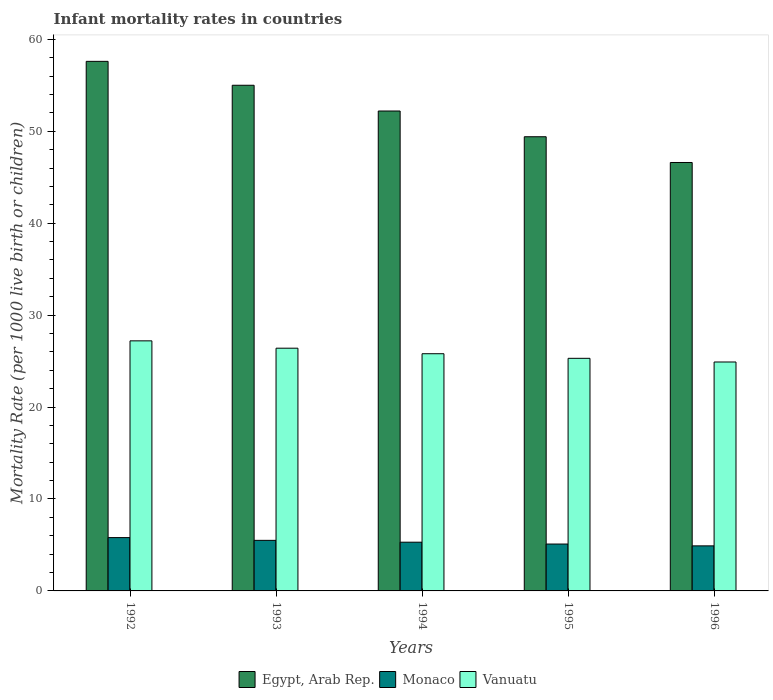How many bars are there on the 1st tick from the right?
Give a very brief answer. 3. What is the label of the 1st group of bars from the left?
Ensure brevity in your answer.  1992. In how many cases, is the number of bars for a given year not equal to the number of legend labels?
Ensure brevity in your answer.  0. What is the infant mortality rate in Vanuatu in 1992?
Ensure brevity in your answer.  27.2. Across all years, what is the maximum infant mortality rate in Monaco?
Give a very brief answer. 5.8. Across all years, what is the minimum infant mortality rate in Monaco?
Your response must be concise. 4.9. In which year was the infant mortality rate in Vanuatu maximum?
Make the answer very short. 1992. In which year was the infant mortality rate in Monaco minimum?
Give a very brief answer. 1996. What is the total infant mortality rate in Monaco in the graph?
Your answer should be compact. 26.6. What is the difference between the infant mortality rate in Egypt, Arab Rep. in 1993 and that in 1995?
Ensure brevity in your answer.  5.6. What is the difference between the infant mortality rate in Egypt, Arab Rep. in 1994 and the infant mortality rate in Monaco in 1995?
Your answer should be compact. 47.1. What is the average infant mortality rate in Vanuatu per year?
Offer a very short reply. 25.92. In the year 1996, what is the difference between the infant mortality rate in Egypt, Arab Rep. and infant mortality rate in Vanuatu?
Provide a succinct answer. 21.7. In how many years, is the infant mortality rate in Monaco greater than 14?
Make the answer very short. 0. What is the ratio of the infant mortality rate in Monaco in 1995 to that in 1996?
Make the answer very short. 1.04. Is the infant mortality rate in Monaco in 1992 less than that in 1995?
Offer a terse response. No. What is the difference between the highest and the second highest infant mortality rate in Vanuatu?
Provide a succinct answer. 0.8. What is the difference between the highest and the lowest infant mortality rate in Vanuatu?
Your answer should be compact. 2.3. Is the sum of the infant mortality rate in Vanuatu in 1993 and 1994 greater than the maximum infant mortality rate in Monaco across all years?
Provide a succinct answer. Yes. What does the 2nd bar from the left in 1993 represents?
Keep it short and to the point. Monaco. What does the 2nd bar from the right in 1993 represents?
Keep it short and to the point. Monaco. Are all the bars in the graph horizontal?
Offer a very short reply. No. How many years are there in the graph?
Offer a very short reply. 5. What is the difference between two consecutive major ticks on the Y-axis?
Provide a succinct answer. 10. Are the values on the major ticks of Y-axis written in scientific E-notation?
Your answer should be compact. No. Does the graph contain any zero values?
Offer a very short reply. No. Does the graph contain grids?
Your response must be concise. No. How are the legend labels stacked?
Provide a succinct answer. Horizontal. What is the title of the graph?
Offer a terse response. Infant mortality rates in countries. Does "Malaysia" appear as one of the legend labels in the graph?
Your response must be concise. No. What is the label or title of the Y-axis?
Keep it short and to the point. Mortality Rate (per 1000 live birth or children). What is the Mortality Rate (per 1000 live birth or children) of Egypt, Arab Rep. in 1992?
Give a very brief answer. 57.6. What is the Mortality Rate (per 1000 live birth or children) in Monaco in 1992?
Your response must be concise. 5.8. What is the Mortality Rate (per 1000 live birth or children) in Vanuatu in 1992?
Give a very brief answer. 27.2. What is the Mortality Rate (per 1000 live birth or children) of Vanuatu in 1993?
Offer a terse response. 26.4. What is the Mortality Rate (per 1000 live birth or children) in Egypt, Arab Rep. in 1994?
Your response must be concise. 52.2. What is the Mortality Rate (per 1000 live birth or children) of Vanuatu in 1994?
Your answer should be compact. 25.8. What is the Mortality Rate (per 1000 live birth or children) of Egypt, Arab Rep. in 1995?
Give a very brief answer. 49.4. What is the Mortality Rate (per 1000 live birth or children) in Monaco in 1995?
Keep it short and to the point. 5.1. What is the Mortality Rate (per 1000 live birth or children) in Vanuatu in 1995?
Make the answer very short. 25.3. What is the Mortality Rate (per 1000 live birth or children) in Egypt, Arab Rep. in 1996?
Your answer should be very brief. 46.6. What is the Mortality Rate (per 1000 live birth or children) of Monaco in 1996?
Provide a short and direct response. 4.9. What is the Mortality Rate (per 1000 live birth or children) in Vanuatu in 1996?
Offer a very short reply. 24.9. Across all years, what is the maximum Mortality Rate (per 1000 live birth or children) in Egypt, Arab Rep.?
Your answer should be very brief. 57.6. Across all years, what is the maximum Mortality Rate (per 1000 live birth or children) of Monaco?
Provide a short and direct response. 5.8. Across all years, what is the maximum Mortality Rate (per 1000 live birth or children) in Vanuatu?
Offer a very short reply. 27.2. Across all years, what is the minimum Mortality Rate (per 1000 live birth or children) of Egypt, Arab Rep.?
Your response must be concise. 46.6. Across all years, what is the minimum Mortality Rate (per 1000 live birth or children) in Vanuatu?
Offer a very short reply. 24.9. What is the total Mortality Rate (per 1000 live birth or children) in Egypt, Arab Rep. in the graph?
Make the answer very short. 260.8. What is the total Mortality Rate (per 1000 live birth or children) of Monaco in the graph?
Offer a very short reply. 26.6. What is the total Mortality Rate (per 1000 live birth or children) in Vanuatu in the graph?
Give a very brief answer. 129.6. What is the difference between the Mortality Rate (per 1000 live birth or children) of Egypt, Arab Rep. in 1992 and that in 1993?
Make the answer very short. 2.6. What is the difference between the Mortality Rate (per 1000 live birth or children) of Vanuatu in 1992 and that in 1993?
Provide a short and direct response. 0.8. What is the difference between the Mortality Rate (per 1000 live birth or children) in Monaco in 1992 and that in 1994?
Your answer should be very brief. 0.5. What is the difference between the Mortality Rate (per 1000 live birth or children) of Vanuatu in 1992 and that in 1995?
Provide a short and direct response. 1.9. What is the difference between the Mortality Rate (per 1000 live birth or children) of Egypt, Arab Rep. in 1992 and that in 1996?
Your answer should be compact. 11. What is the difference between the Mortality Rate (per 1000 live birth or children) of Vanuatu in 1992 and that in 1996?
Give a very brief answer. 2.3. What is the difference between the Mortality Rate (per 1000 live birth or children) of Egypt, Arab Rep. in 1993 and that in 1994?
Keep it short and to the point. 2.8. What is the difference between the Mortality Rate (per 1000 live birth or children) in Egypt, Arab Rep. in 1993 and that in 1995?
Keep it short and to the point. 5.6. What is the difference between the Mortality Rate (per 1000 live birth or children) in Monaco in 1993 and that in 1995?
Give a very brief answer. 0.4. What is the difference between the Mortality Rate (per 1000 live birth or children) in Vanuatu in 1993 and that in 1995?
Provide a short and direct response. 1.1. What is the difference between the Mortality Rate (per 1000 live birth or children) in Egypt, Arab Rep. in 1993 and that in 1996?
Ensure brevity in your answer.  8.4. What is the difference between the Mortality Rate (per 1000 live birth or children) of Vanuatu in 1994 and that in 1995?
Your response must be concise. 0.5. What is the difference between the Mortality Rate (per 1000 live birth or children) of Vanuatu in 1994 and that in 1996?
Provide a short and direct response. 0.9. What is the difference between the Mortality Rate (per 1000 live birth or children) of Egypt, Arab Rep. in 1995 and that in 1996?
Your answer should be compact. 2.8. What is the difference between the Mortality Rate (per 1000 live birth or children) in Vanuatu in 1995 and that in 1996?
Ensure brevity in your answer.  0.4. What is the difference between the Mortality Rate (per 1000 live birth or children) of Egypt, Arab Rep. in 1992 and the Mortality Rate (per 1000 live birth or children) of Monaco in 1993?
Your response must be concise. 52.1. What is the difference between the Mortality Rate (per 1000 live birth or children) of Egypt, Arab Rep. in 1992 and the Mortality Rate (per 1000 live birth or children) of Vanuatu in 1993?
Give a very brief answer. 31.2. What is the difference between the Mortality Rate (per 1000 live birth or children) in Monaco in 1992 and the Mortality Rate (per 1000 live birth or children) in Vanuatu in 1993?
Your answer should be very brief. -20.6. What is the difference between the Mortality Rate (per 1000 live birth or children) in Egypt, Arab Rep. in 1992 and the Mortality Rate (per 1000 live birth or children) in Monaco in 1994?
Your response must be concise. 52.3. What is the difference between the Mortality Rate (per 1000 live birth or children) of Egypt, Arab Rep. in 1992 and the Mortality Rate (per 1000 live birth or children) of Vanuatu in 1994?
Provide a short and direct response. 31.8. What is the difference between the Mortality Rate (per 1000 live birth or children) of Egypt, Arab Rep. in 1992 and the Mortality Rate (per 1000 live birth or children) of Monaco in 1995?
Your response must be concise. 52.5. What is the difference between the Mortality Rate (per 1000 live birth or children) of Egypt, Arab Rep. in 1992 and the Mortality Rate (per 1000 live birth or children) of Vanuatu in 1995?
Offer a terse response. 32.3. What is the difference between the Mortality Rate (per 1000 live birth or children) of Monaco in 1992 and the Mortality Rate (per 1000 live birth or children) of Vanuatu in 1995?
Your response must be concise. -19.5. What is the difference between the Mortality Rate (per 1000 live birth or children) of Egypt, Arab Rep. in 1992 and the Mortality Rate (per 1000 live birth or children) of Monaco in 1996?
Your response must be concise. 52.7. What is the difference between the Mortality Rate (per 1000 live birth or children) of Egypt, Arab Rep. in 1992 and the Mortality Rate (per 1000 live birth or children) of Vanuatu in 1996?
Offer a very short reply. 32.7. What is the difference between the Mortality Rate (per 1000 live birth or children) in Monaco in 1992 and the Mortality Rate (per 1000 live birth or children) in Vanuatu in 1996?
Your answer should be compact. -19.1. What is the difference between the Mortality Rate (per 1000 live birth or children) in Egypt, Arab Rep. in 1993 and the Mortality Rate (per 1000 live birth or children) in Monaco in 1994?
Offer a terse response. 49.7. What is the difference between the Mortality Rate (per 1000 live birth or children) in Egypt, Arab Rep. in 1993 and the Mortality Rate (per 1000 live birth or children) in Vanuatu in 1994?
Your answer should be very brief. 29.2. What is the difference between the Mortality Rate (per 1000 live birth or children) of Monaco in 1993 and the Mortality Rate (per 1000 live birth or children) of Vanuatu in 1994?
Make the answer very short. -20.3. What is the difference between the Mortality Rate (per 1000 live birth or children) in Egypt, Arab Rep. in 1993 and the Mortality Rate (per 1000 live birth or children) in Monaco in 1995?
Your answer should be compact. 49.9. What is the difference between the Mortality Rate (per 1000 live birth or children) of Egypt, Arab Rep. in 1993 and the Mortality Rate (per 1000 live birth or children) of Vanuatu in 1995?
Offer a terse response. 29.7. What is the difference between the Mortality Rate (per 1000 live birth or children) in Monaco in 1993 and the Mortality Rate (per 1000 live birth or children) in Vanuatu in 1995?
Ensure brevity in your answer.  -19.8. What is the difference between the Mortality Rate (per 1000 live birth or children) in Egypt, Arab Rep. in 1993 and the Mortality Rate (per 1000 live birth or children) in Monaco in 1996?
Provide a short and direct response. 50.1. What is the difference between the Mortality Rate (per 1000 live birth or children) in Egypt, Arab Rep. in 1993 and the Mortality Rate (per 1000 live birth or children) in Vanuatu in 1996?
Your answer should be compact. 30.1. What is the difference between the Mortality Rate (per 1000 live birth or children) of Monaco in 1993 and the Mortality Rate (per 1000 live birth or children) of Vanuatu in 1996?
Provide a succinct answer. -19.4. What is the difference between the Mortality Rate (per 1000 live birth or children) of Egypt, Arab Rep. in 1994 and the Mortality Rate (per 1000 live birth or children) of Monaco in 1995?
Give a very brief answer. 47.1. What is the difference between the Mortality Rate (per 1000 live birth or children) of Egypt, Arab Rep. in 1994 and the Mortality Rate (per 1000 live birth or children) of Vanuatu in 1995?
Your answer should be compact. 26.9. What is the difference between the Mortality Rate (per 1000 live birth or children) of Monaco in 1994 and the Mortality Rate (per 1000 live birth or children) of Vanuatu in 1995?
Provide a succinct answer. -20. What is the difference between the Mortality Rate (per 1000 live birth or children) of Egypt, Arab Rep. in 1994 and the Mortality Rate (per 1000 live birth or children) of Monaco in 1996?
Ensure brevity in your answer.  47.3. What is the difference between the Mortality Rate (per 1000 live birth or children) in Egypt, Arab Rep. in 1994 and the Mortality Rate (per 1000 live birth or children) in Vanuatu in 1996?
Your response must be concise. 27.3. What is the difference between the Mortality Rate (per 1000 live birth or children) in Monaco in 1994 and the Mortality Rate (per 1000 live birth or children) in Vanuatu in 1996?
Offer a terse response. -19.6. What is the difference between the Mortality Rate (per 1000 live birth or children) in Egypt, Arab Rep. in 1995 and the Mortality Rate (per 1000 live birth or children) in Monaco in 1996?
Keep it short and to the point. 44.5. What is the difference between the Mortality Rate (per 1000 live birth or children) of Egypt, Arab Rep. in 1995 and the Mortality Rate (per 1000 live birth or children) of Vanuatu in 1996?
Ensure brevity in your answer.  24.5. What is the difference between the Mortality Rate (per 1000 live birth or children) in Monaco in 1995 and the Mortality Rate (per 1000 live birth or children) in Vanuatu in 1996?
Your response must be concise. -19.8. What is the average Mortality Rate (per 1000 live birth or children) of Egypt, Arab Rep. per year?
Make the answer very short. 52.16. What is the average Mortality Rate (per 1000 live birth or children) of Monaco per year?
Offer a terse response. 5.32. What is the average Mortality Rate (per 1000 live birth or children) in Vanuatu per year?
Your answer should be very brief. 25.92. In the year 1992, what is the difference between the Mortality Rate (per 1000 live birth or children) in Egypt, Arab Rep. and Mortality Rate (per 1000 live birth or children) in Monaco?
Your answer should be very brief. 51.8. In the year 1992, what is the difference between the Mortality Rate (per 1000 live birth or children) of Egypt, Arab Rep. and Mortality Rate (per 1000 live birth or children) of Vanuatu?
Offer a terse response. 30.4. In the year 1992, what is the difference between the Mortality Rate (per 1000 live birth or children) in Monaco and Mortality Rate (per 1000 live birth or children) in Vanuatu?
Ensure brevity in your answer.  -21.4. In the year 1993, what is the difference between the Mortality Rate (per 1000 live birth or children) in Egypt, Arab Rep. and Mortality Rate (per 1000 live birth or children) in Monaco?
Ensure brevity in your answer.  49.5. In the year 1993, what is the difference between the Mortality Rate (per 1000 live birth or children) in Egypt, Arab Rep. and Mortality Rate (per 1000 live birth or children) in Vanuatu?
Offer a terse response. 28.6. In the year 1993, what is the difference between the Mortality Rate (per 1000 live birth or children) in Monaco and Mortality Rate (per 1000 live birth or children) in Vanuatu?
Your answer should be compact. -20.9. In the year 1994, what is the difference between the Mortality Rate (per 1000 live birth or children) in Egypt, Arab Rep. and Mortality Rate (per 1000 live birth or children) in Monaco?
Your response must be concise. 46.9. In the year 1994, what is the difference between the Mortality Rate (per 1000 live birth or children) of Egypt, Arab Rep. and Mortality Rate (per 1000 live birth or children) of Vanuatu?
Ensure brevity in your answer.  26.4. In the year 1994, what is the difference between the Mortality Rate (per 1000 live birth or children) in Monaco and Mortality Rate (per 1000 live birth or children) in Vanuatu?
Give a very brief answer. -20.5. In the year 1995, what is the difference between the Mortality Rate (per 1000 live birth or children) in Egypt, Arab Rep. and Mortality Rate (per 1000 live birth or children) in Monaco?
Give a very brief answer. 44.3. In the year 1995, what is the difference between the Mortality Rate (per 1000 live birth or children) of Egypt, Arab Rep. and Mortality Rate (per 1000 live birth or children) of Vanuatu?
Ensure brevity in your answer.  24.1. In the year 1995, what is the difference between the Mortality Rate (per 1000 live birth or children) in Monaco and Mortality Rate (per 1000 live birth or children) in Vanuatu?
Make the answer very short. -20.2. In the year 1996, what is the difference between the Mortality Rate (per 1000 live birth or children) in Egypt, Arab Rep. and Mortality Rate (per 1000 live birth or children) in Monaco?
Give a very brief answer. 41.7. In the year 1996, what is the difference between the Mortality Rate (per 1000 live birth or children) in Egypt, Arab Rep. and Mortality Rate (per 1000 live birth or children) in Vanuatu?
Ensure brevity in your answer.  21.7. What is the ratio of the Mortality Rate (per 1000 live birth or children) of Egypt, Arab Rep. in 1992 to that in 1993?
Provide a short and direct response. 1.05. What is the ratio of the Mortality Rate (per 1000 live birth or children) in Monaco in 1992 to that in 1993?
Make the answer very short. 1.05. What is the ratio of the Mortality Rate (per 1000 live birth or children) in Vanuatu in 1992 to that in 1993?
Provide a short and direct response. 1.03. What is the ratio of the Mortality Rate (per 1000 live birth or children) of Egypt, Arab Rep. in 1992 to that in 1994?
Provide a short and direct response. 1.1. What is the ratio of the Mortality Rate (per 1000 live birth or children) of Monaco in 1992 to that in 1994?
Offer a terse response. 1.09. What is the ratio of the Mortality Rate (per 1000 live birth or children) in Vanuatu in 1992 to that in 1994?
Offer a very short reply. 1.05. What is the ratio of the Mortality Rate (per 1000 live birth or children) in Egypt, Arab Rep. in 1992 to that in 1995?
Offer a very short reply. 1.17. What is the ratio of the Mortality Rate (per 1000 live birth or children) of Monaco in 1992 to that in 1995?
Give a very brief answer. 1.14. What is the ratio of the Mortality Rate (per 1000 live birth or children) of Vanuatu in 1992 to that in 1995?
Keep it short and to the point. 1.08. What is the ratio of the Mortality Rate (per 1000 live birth or children) in Egypt, Arab Rep. in 1992 to that in 1996?
Your answer should be very brief. 1.24. What is the ratio of the Mortality Rate (per 1000 live birth or children) in Monaco in 1992 to that in 1996?
Provide a succinct answer. 1.18. What is the ratio of the Mortality Rate (per 1000 live birth or children) in Vanuatu in 1992 to that in 1996?
Your answer should be very brief. 1.09. What is the ratio of the Mortality Rate (per 1000 live birth or children) in Egypt, Arab Rep. in 1993 to that in 1994?
Give a very brief answer. 1.05. What is the ratio of the Mortality Rate (per 1000 live birth or children) in Monaco in 1993 to that in 1994?
Your answer should be very brief. 1.04. What is the ratio of the Mortality Rate (per 1000 live birth or children) of Vanuatu in 1993 to that in 1994?
Give a very brief answer. 1.02. What is the ratio of the Mortality Rate (per 1000 live birth or children) of Egypt, Arab Rep. in 1993 to that in 1995?
Your answer should be compact. 1.11. What is the ratio of the Mortality Rate (per 1000 live birth or children) of Monaco in 1993 to that in 1995?
Keep it short and to the point. 1.08. What is the ratio of the Mortality Rate (per 1000 live birth or children) in Vanuatu in 1993 to that in 1995?
Offer a terse response. 1.04. What is the ratio of the Mortality Rate (per 1000 live birth or children) in Egypt, Arab Rep. in 1993 to that in 1996?
Your answer should be very brief. 1.18. What is the ratio of the Mortality Rate (per 1000 live birth or children) in Monaco in 1993 to that in 1996?
Offer a terse response. 1.12. What is the ratio of the Mortality Rate (per 1000 live birth or children) in Vanuatu in 1993 to that in 1996?
Ensure brevity in your answer.  1.06. What is the ratio of the Mortality Rate (per 1000 live birth or children) in Egypt, Arab Rep. in 1994 to that in 1995?
Offer a terse response. 1.06. What is the ratio of the Mortality Rate (per 1000 live birth or children) in Monaco in 1994 to that in 1995?
Provide a succinct answer. 1.04. What is the ratio of the Mortality Rate (per 1000 live birth or children) of Vanuatu in 1994 to that in 1995?
Make the answer very short. 1.02. What is the ratio of the Mortality Rate (per 1000 live birth or children) of Egypt, Arab Rep. in 1994 to that in 1996?
Your response must be concise. 1.12. What is the ratio of the Mortality Rate (per 1000 live birth or children) of Monaco in 1994 to that in 1996?
Your response must be concise. 1.08. What is the ratio of the Mortality Rate (per 1000 live birth or children) of Vanuatu in 1994 to that in 1996?
Make the answer very short. 1.04. What is the ratio of the Mortality Rate (per 1000 live birth or children) of Egypt, Arab Rep. in 1995 to that in 1996?
Give a very brief answer. 1.06. What is the ratio of the Mortality Rate (per 1000 live birth or children) of Monaco in 1995 to that in 1996?
Your answer should be compact. 1.04. What is the ratio of the Mortality Rate (per 1000 live birth or children) of Vanuatu in 1995 to that in 1996?
Give a very brief answer. 1.02. What is the difference between the highest and the second highest Mortality Rate (per 1000 live birth or children) of Egypt, Arab Rep.?
Your answer should be very brief. 2.6. What is the difference between the highest and the lowest Mortality Rate (per 1000 live birth or children) in Monaco?
Offer a terse response. 0.9. 